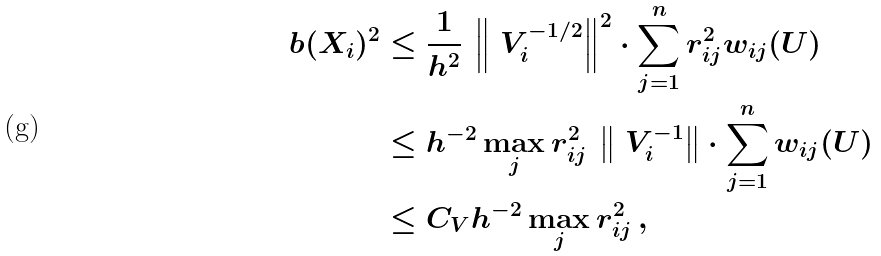<formula> <loc_0><loc_0><loc_500><loc_500>b ( X _ { i } ) ^ { 2 } & \leq \frac { 1 } { h ^ { 2 } } \, \left \| \ V _ { i } ^ { - 1 / 2 } \right \| ^ { 2 } \cdot \sum _ { j = 1 } ^ { n } r _ { i j } ^ { 2 } w _ { i j } ( U ) \\ & \leq h ^ { - 2 } \max _ { j } r _ { i j } ^ { 2 } \, \left \| \ V _ { i } ^ { - 1 } \right \| \cdot \sum _ { j = 1 } ^ { n } w _ { i j } ( U ) \\ & \leq C _ { V } h ^ { - 2 } \max _ { j } r _ { i j } ^ { 2 } \, ,</formula> 